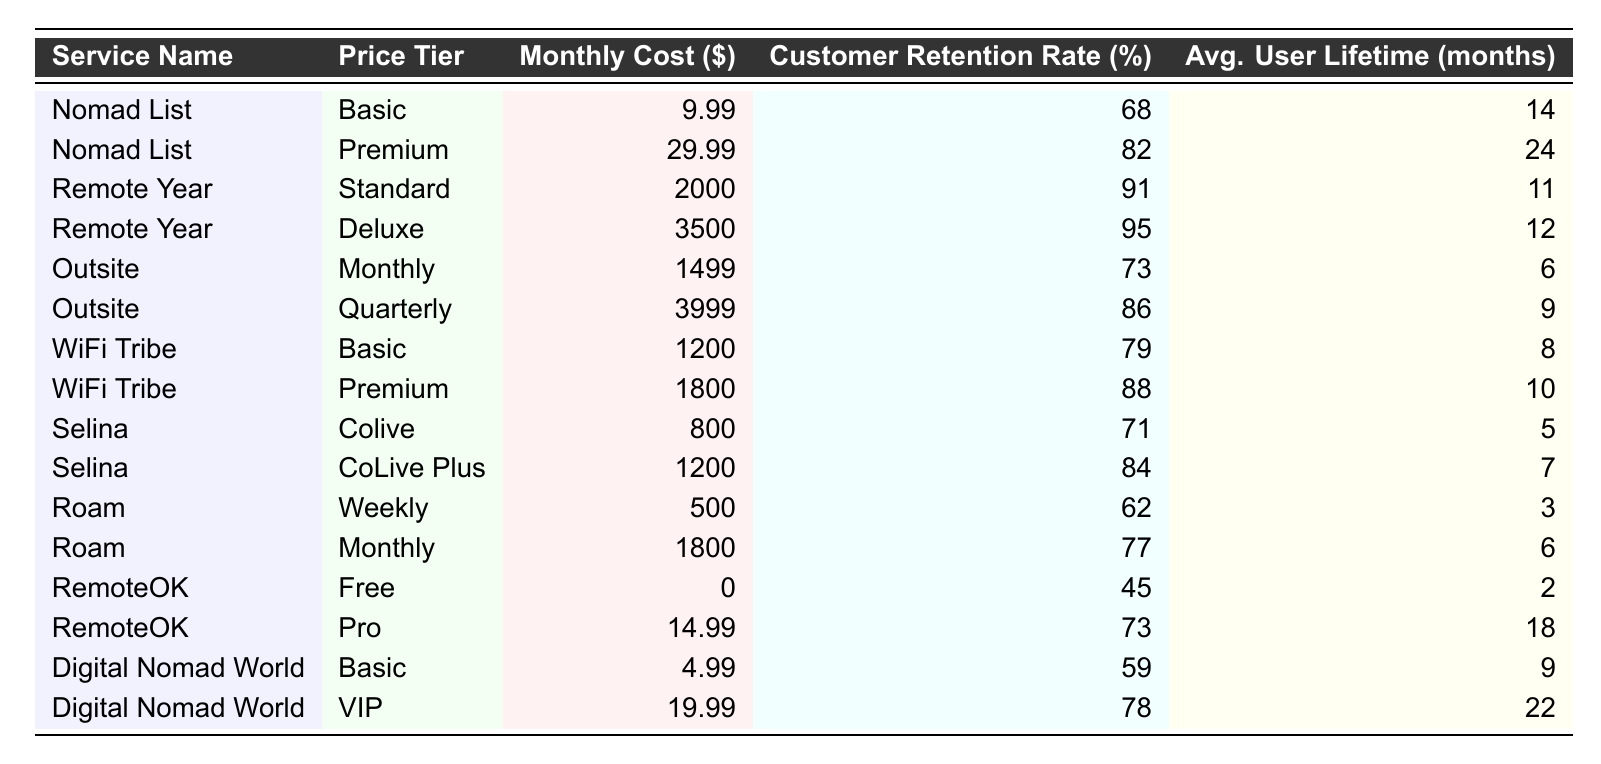What is the customer retention rate for the Premium tier of Nomad List? The table shows that the customer retention rate for the Premium tier of Nomad List is listed as 82%.
Answer: 82% Which service has the highest customer retention rate? According to the table, Remote Year in the Deluxe tier has the highest customer retention rate at 95%.
Answer: 95% What is the average customer retention rate for all services below $1000 in monthly cost? Firstly, we identify the services below $1000, which are: Digital Nomad World Basic (59%), RemoteOK Free (45%), and Selina Colive (71%). Then, we calculate the average: (59 + 45 + 71) / 3 = 55%.
Answer: 55% Is there any service with a customer retention rate below 60%? Yes, the RemoteOK Free service has a customer retention rate of 45%, which is below 60%.
Answer: Yes What is the difference in the average user lifetime between the Deluxe tier of Remote Year and the Basic tier of Nomad List? The average user lifetime for Deluxe tier of Remote Year is 12 months, and for Basic tier of Nomad List, it is 14 months. The difference is 14 - 12 = 2 months.
Answer: 2 months What percentage of service offerings have a customer retention rate above 80%? There are a total of 16 services listed. Of these, six services have a retention rate above 80% (Nomad List Premium, Remote Year Standard, Remote Year Deluxe, Outsite Quarterly, WiFi Tribe Premium, Digital Nomad World VIP). The percentage is (6/16) * 100 = 37.5%.
Answer: 37.5% How does the customer retention rate of Selina's CoLive Plus compare with WiFi Tribe's Premium tier? Selina's CoLive Plus has a retention rate of 84%, while WiFi Tribe's Premium tier has a retention rate of 88%. WiFi Tribe's rate is higher by 4%.
Answer: 4% higher What is the average monthly cost of the services with a customer retention rate of 75% or above? The qualifying services are: Nomad List Premium ($29.99), Remote Year Standard ($2000), Remote Year Deluxe ($3500), Outsite Quarterly ($3999), WiFi Tribe Premium ($1800), and Digital Nomad World VIP ($19.99). Their average monthly cost is (29.99 + 2000 + 3500 + 3999 + 1800 + 19.99) / 6 = $1771.49.
Answer: $1771.49 Which price tier has the lowest average user lifetime and what is that value? Roam's Weekly tier has the lowest average user lifetime of 3 months.
Answer: 3 months What is the customer retention rate of RemoteOK's Pro service? The customer retention rate for RemoteOK Pro is 73%, as per the table.
Answer: 73% Is Digital Nomad World the lowest-priced service in the table? Yes, Digital Nomad World Basic has the lowest price at $4.99, making it the lowest-priced service listed.
Answer: Yes 